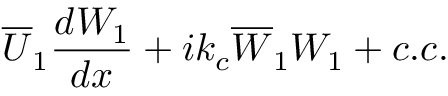Convert formula to latex. <formula><loc_0><loc_0><loc_500><loc_500>\overline { U } _ { 1 } \frac { d W _ { 1 } } { d x } + i k _ { c } \overline { W } _ { 1 } W _ { 1 } + c . c .</formula> 